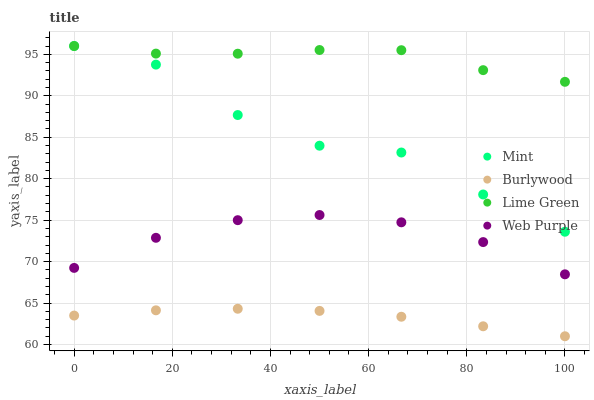Does Burlywood have the minimum area under the curve?
Answer yes or no. Yes. Does Lime Green have the maximum area under the curve?
Answer yes or no. Yes. Does Web Purple have the minimum area under the curve?
Answer yes or no. No. Does Web Purple have the maximum area under the curve?
Answer yes or no. No. Is Burlywood the smoothest?
Answer yes or no. Yes. Is Mint the roughest?
Answer yes or no. Yes. Is Lime Green the smoothest?
Answer yes or no. No. Is Lime Green the roughest?
Answer yes or no. No. Does Burlywood have the lowest value?
Answer yes or no. Yes. Does Web Purple have the lowest value?
Answer yes or no. No. Does Mint have the highest value?
Answer yes or no. Yes. Does Web Purple have the highest value?
Answer yes or no. No. Is Web Purple less than Lime Green?
Answer yes or no. Yes. Is Mint greater than Burlywood?
Answer yes or no. Yes. Does Lime Green intersect Mint?
Answer yes or no. Yes. Is Lime Green less than Mint?
Answer yes or no. No. Is Lime Green greater than Mint?
Answer yes or no. No. Does Web Purple intersect Lime Green?
Answer yes or no. No. 